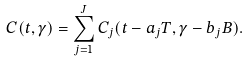<formula> <loc_0><loc_0><loc_500><loc_500>C ( t , \gamma ) = \sum _ { j = 1 } ^ { J } C _ { j } ( t - a _ { j } T , \gamma - b _ { j } B ) .</formula> 